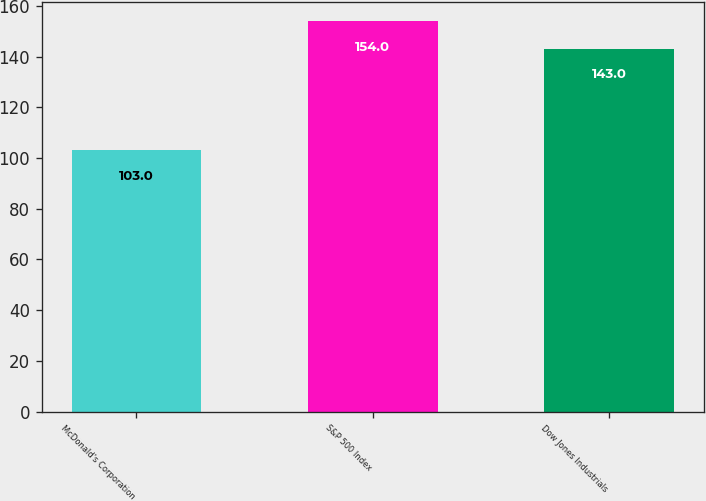Convert chart to OTSL. <chart><loc_0><loc_0><loc_500><loc_500><bar_chart><fcel>McDonald's Corporation<fcel>S&P 500 Index<fcel>Dow Jones Industrials<nl><fcel>103<fcel>154<fcel>143<nl></chart> 